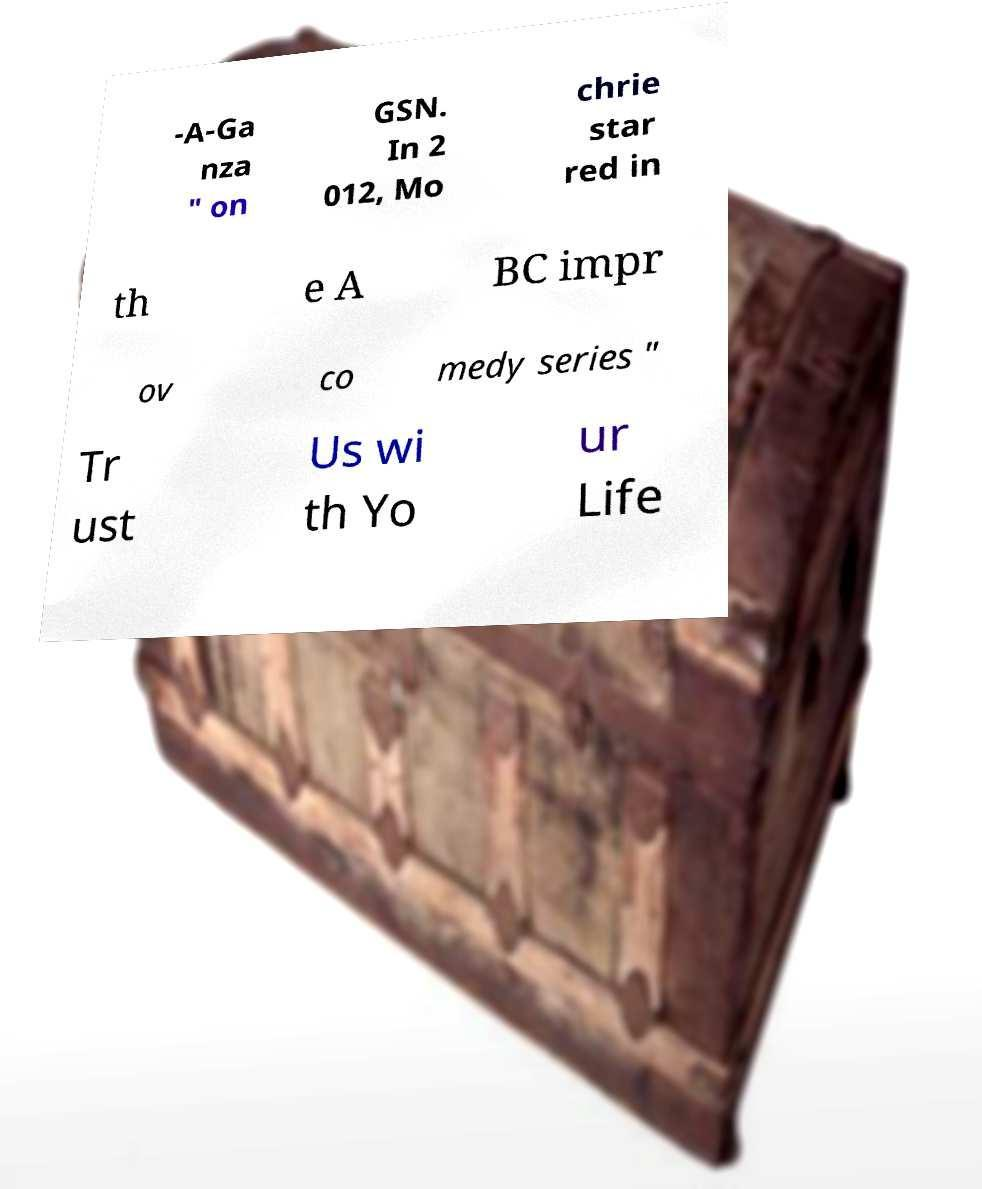I need the written content from this picture converted into text. Can you do that? -A-Ga nza " on GSN. In 2 012, Mo chrie star red in th e A BC impr ov co medy series " Tr ust Us wi th Yo ur Life 